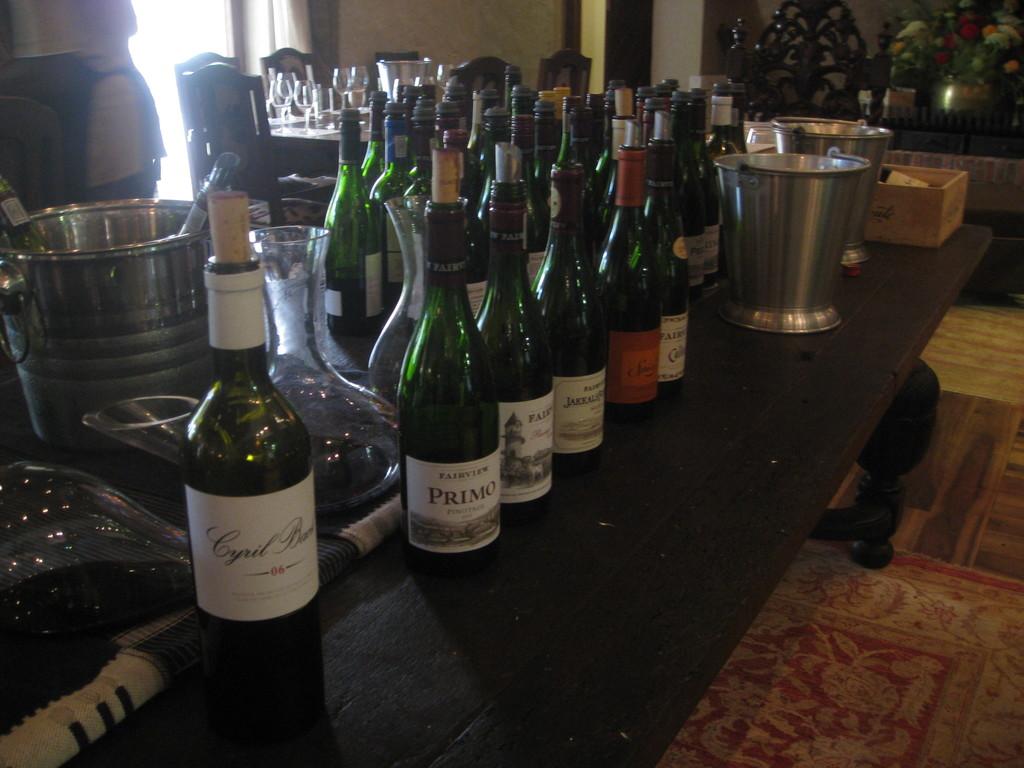What is the second bottle from the left?
Ensure brevity in your answer.  Primo. 